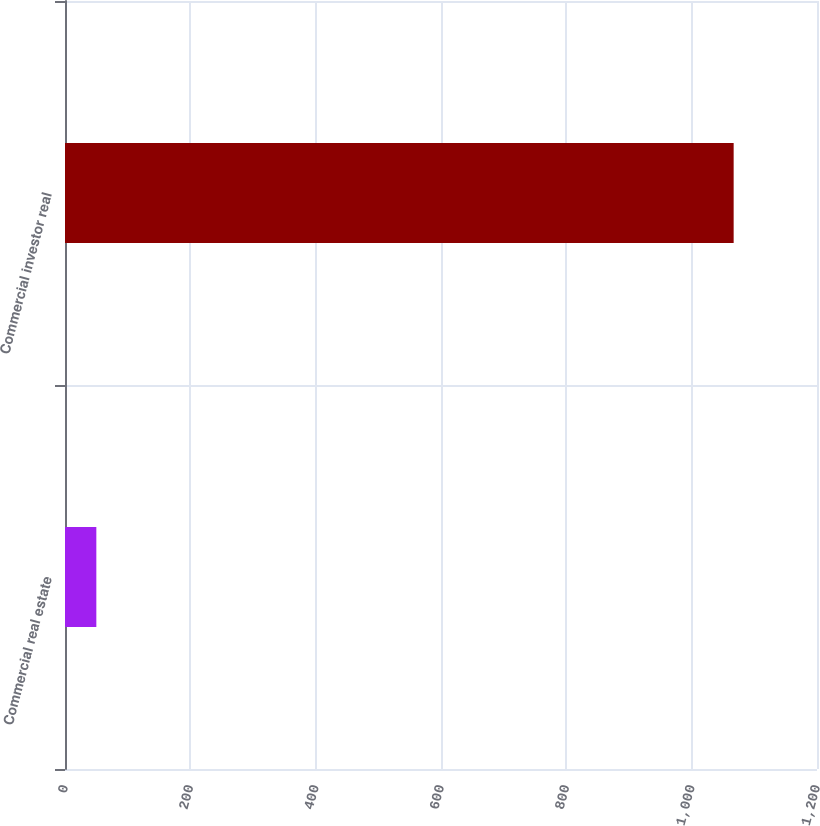<chart> <loc_0><loc_0><loc_500><loc_500><bar_chart><fcel>Commercial real estate<fcel>Commercial investor real<nl><fcel>50<fcel>1067<nl></chart> 